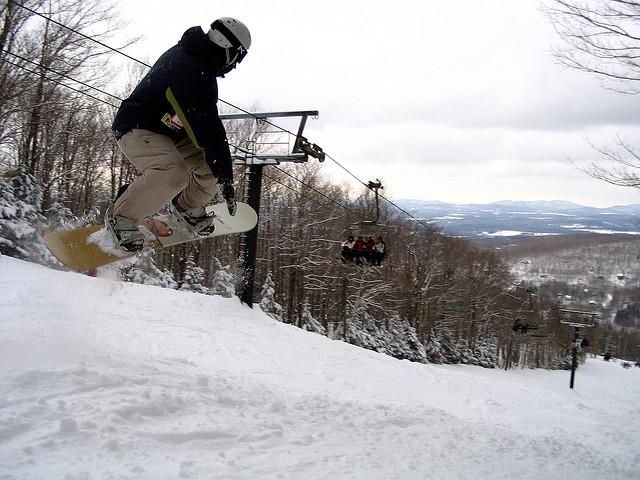Are all of the chairs on the chairlift empty?
Short answer required. No. Is the man snowboarding?
Be succinct. Yes. What color is the man's helmet?
Short answer required. White. 